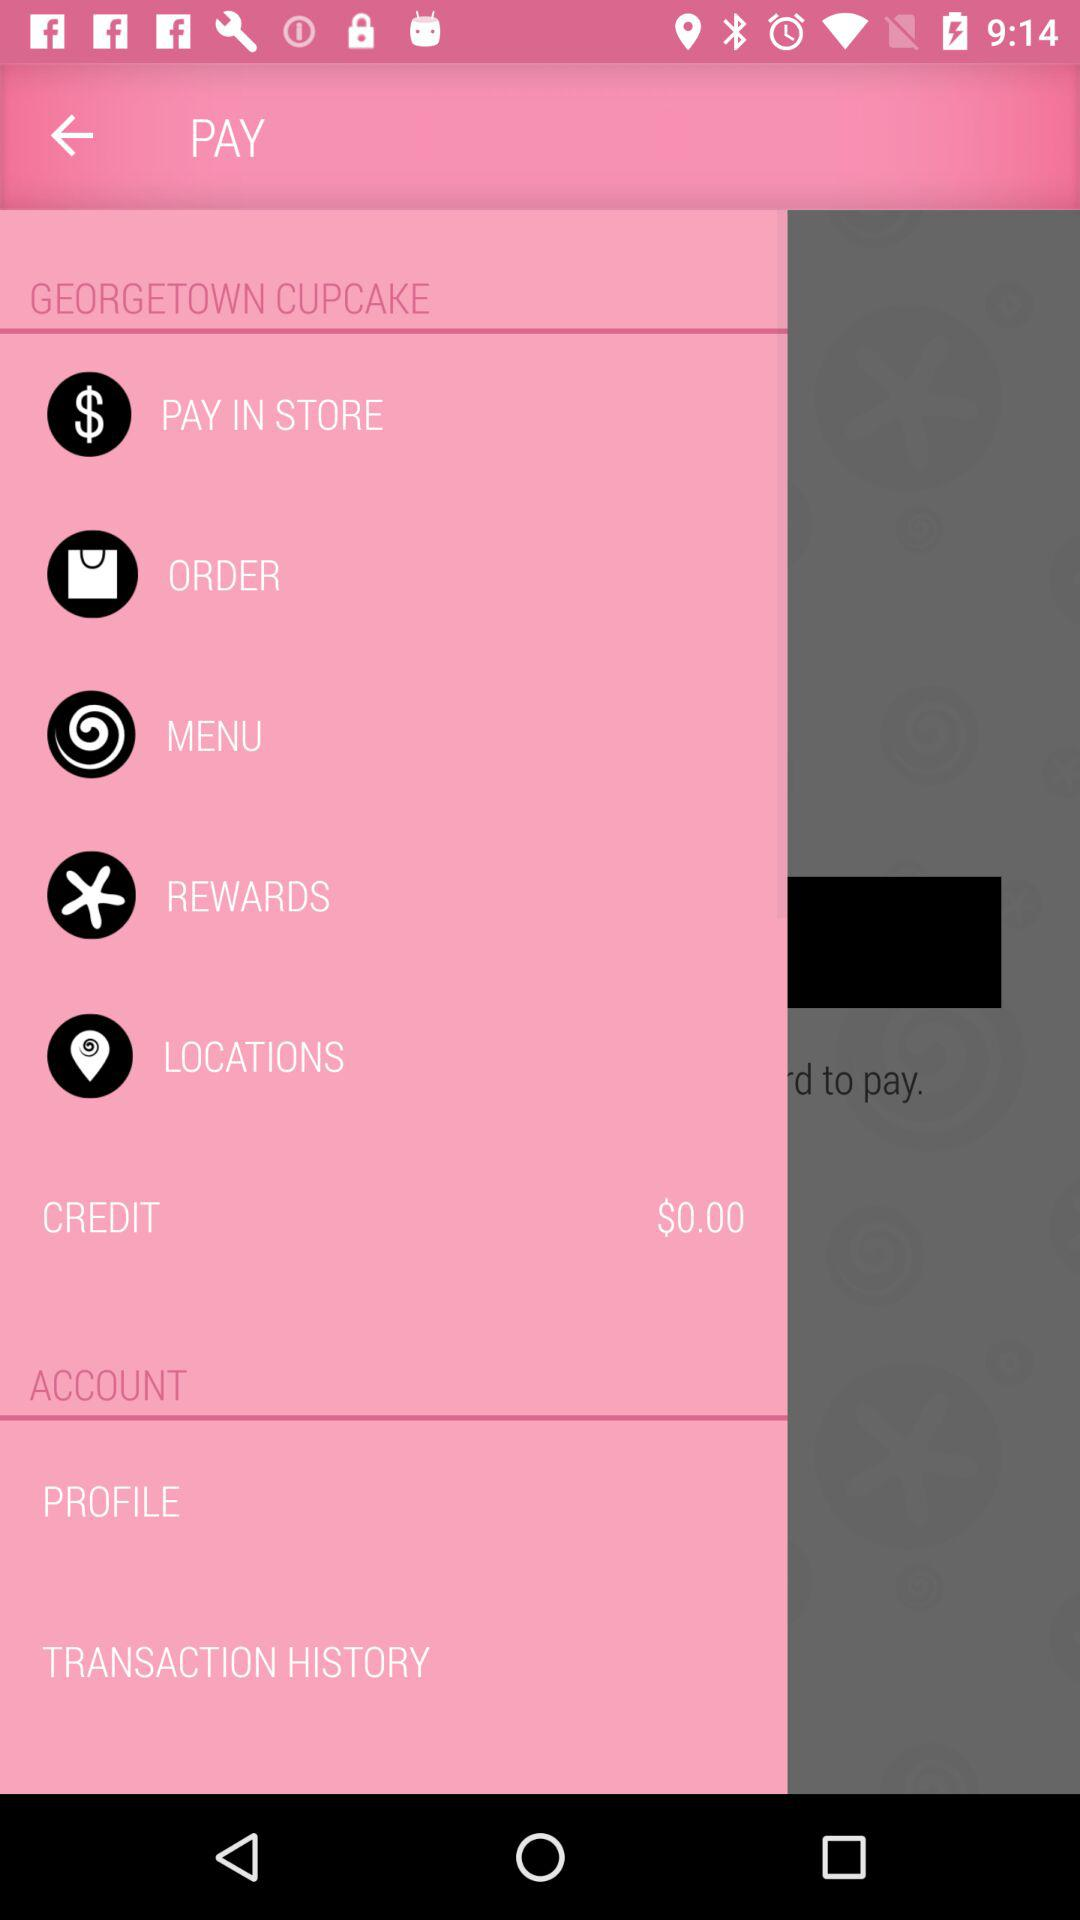What is the amount of credit? The amount of credit is $0.00. 